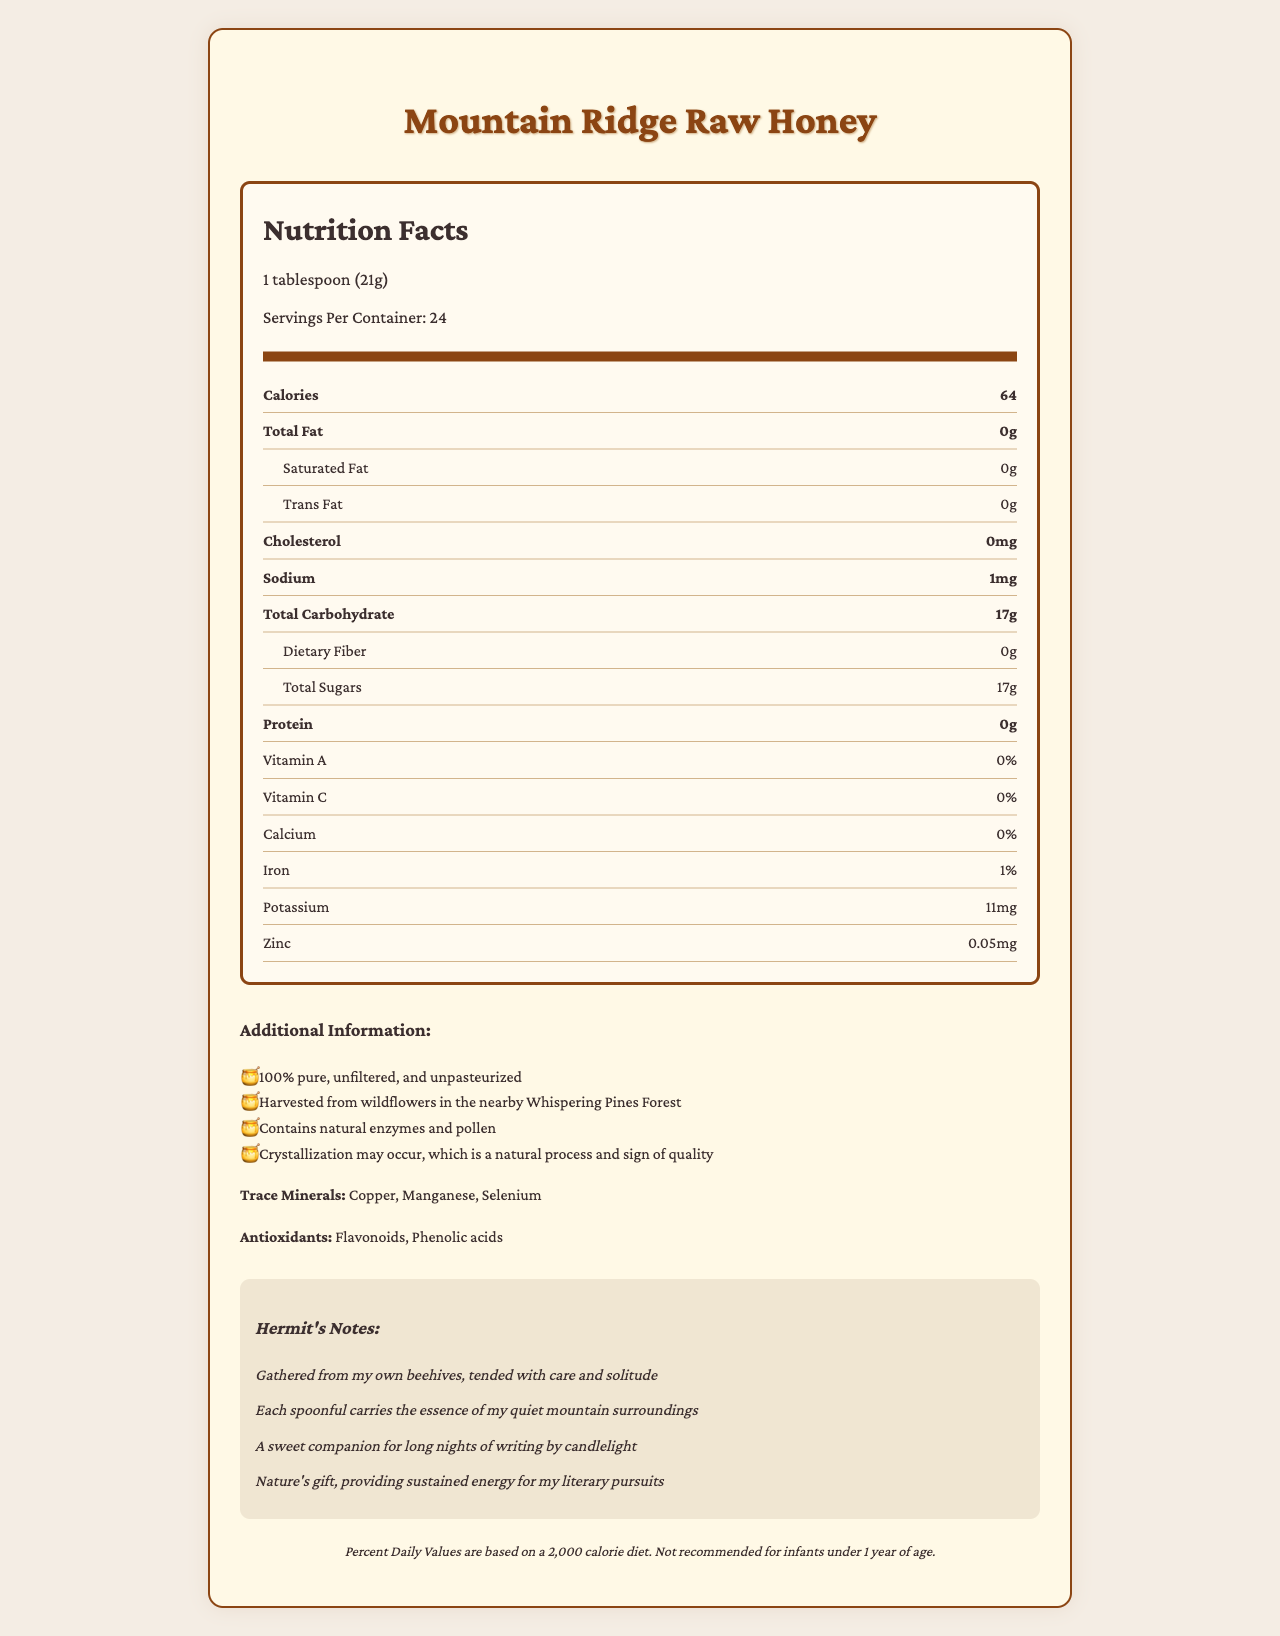what is the serving size for Mountain Ridge Raw Honey? The serving size is clearly labeled as "1 tablespoon (21g)" in the document.
Answer: 1 tablespoon (21g) how many calories are in one serving of Mountain Ridge Raw Honey? The document specifies that each serving contains 64 calories.
Answer: 64 which trace minerals are present in Mountain Ridge Raw Honey? A. Copper, Zinc, Selenium B. Manganese, Iron, Zinc C. Copper, Manganese, Selenium D. Iron, Potassium, Zinc The document lists the trace minerals as Copper, Manganese, and Selenium.
Answer: C. Copper, Manganese, Selenium what additional information is provided about the honey? The additional information section lists several details about the honey, including its purity, source, contents, and crystallization.
Answer: 100% pure, unfiltered, and unpasteurized; Harvested from wildflowers in the nearby Whispering Pines Forest; Contains natural enzymes and pollen; Crystallization may occur, which is a natural process and sign of quality how much sodium is in a serving? The document states that there is 1mg of sodium per serving.
Answer: 1mg are there any dietary fibers in Mountain Ridge Raw Honey? The document shows that the dietary fiber content is 0g, indicating there is no dietary fiber.
Answer: No what is the iron content in Mountain Ridge Raw Honey? The document indicates that the iron content is 1% of the daily value.
Answer: 1% does the honey include any proteins? The document states that the protein content is 0g.
Answer: No is Mountain Ridge Raw Honey recommended for infants under 1 year of age? The disclaimer clearly states that it is not recommended for infants under 1 year of age.
Answer: No what vitamins are listed in the nutrition information? The document provides values for Vitamin A (0%) and Vitamin C (0%).
Answer: Vitamin A: 0%, Vitamin C: 0% how many servings are in a container of Mountain Ridge Raw Honey? The document indicates that there are 24 servings per container.
Answer: 24 describe the overall sentiment or main idea of the hermit's notes section The hermit's notes mention the care in gathering the honey, its connection to the mountain surroundings, its role in providing energy for writing by candlelight, and its value as a natural gift.
Answer: The hermit's notes emphasize the personal care and solitude involved in producing the honey, highlighting its natural and energizing qualities and how it complements a solitary writing lifestyle. what is the source of the honey? The additional information specifies that the honey is harvested from wildflowers in the Whispering Pines Forest.
Answer: Harvested from wildflowers in the nearby Whispering Pines Forest what are the two antioxidants mentioned in the document? A. Flavonoids and Ascorbic acid B. Tannins and Citric acid C. Flavonoids and Phenolic acids D. Ascorbic acid and Flavonoids The antioxidants listed are Flavonoids and Phenolic acids.
Answer: C. Flavonoids and Phenolic acids does the document provide specific beekeeper techniques used in gathering the honey? The document mentions that the honey is gathered from the hermit's own beehives and tended with care but does not provide specific details about the techniques used.
Answer: Not enough information does crystallization indicate poor quality in this honey? The additional information notes that crystallization may occur and is a natural process and sign of quality.
Answer: No 